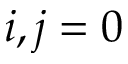<formula> <loc_0><loc_0><loc_500><loc_500>i , j = 0</formula> 